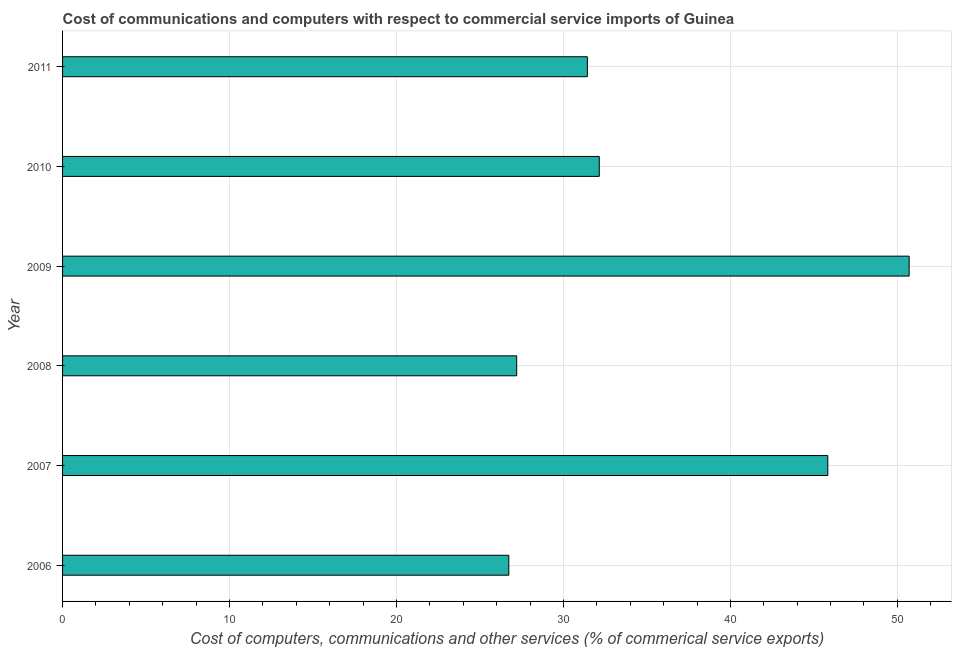Does the graph contain any zero values?
Offer a terse response. No. Does the graph contain grids?
Provide a succinct answer. Yes. What is the title of the graph?
Offer a terse response. Cost of communications and computers with respect to commercial service imports of Guinea. What is the label or title of the X-axis?
Keep it short and to the point. Cost of computers, communications and other services (% of commerical service exports). What is the label or title of the Y-axis?
Ensure brevity in your answer.  Year. What is the cost of communications in 2011?
Make the answer very short. 31.43. Across all years, what is the maximum cost of communications?
Your response must be concise. 50.71. Across all years, what is the minimum  computer and other services?
Keep it short and to the point. 26.73. In which year was the  computer and other services maximum?
Make the answer very short. 2009. What is the sum of the cost of communications?
Your answer should be compact. 214.05. What is the difference between the  computer and other services in 2009 and 2010?
Your response must be concise. 18.56. What is the average  computer and other services per year?
Your response must be concise. 35.67. What is the median  computer and other services?
Offer a terse response. 31.79. In how many years, is the cost of communications greater than 24 %?
Make the answer very short. 6. Do a majority of the years between 2006 and 2011 (inclusive) have  computer and other services greater than 8 %?
Your answer should be compact. Yes. What is the ratio of the  computer and other services in 2006 to that in 2011?
Your answer should be compact. 0.85. Is the  computer and other services in 2007 less than that in 2008?
Offer a very short reply. No. What is the difference between the highest and the second highest cost of communications?
Make the answer very short. 4.87. Is the sum of the cost of communications in 2008 and 2009 greater than the maximum cost of communications across all years?
Give a very brief answer. Yes. What is the difference between the highest and the lowest cost of communications?
Ensure brevity in your answer.  23.98. How many bars are there?
Make the answer very short. 6. How many years are there in the graph?
Make the answer very short. 6. Are the values on the major ticks of X-axis written in scientific E-notation?
Your response must be concise. No. What is the Cost of computers, communications and other services (% of commerical service exports) of 2006?
Ensure brevity in your answer.  26.73. What is the Cost of computers, communications and other services (% of commerical service exports) in 2007?
Provide a short and direct response. 45.83. What is the Cost of computers, communications and other services (% of commerical service exports) in 2008?
Your response must be concise. 27.2. What is the Cost of computers, communications and other services (% of commerical service exports) in 2009?
Provide a succinct answer. 50.71. What is the Cost of computers, communications and other services (% of commerical service exports) of 2010?
Offer a terse response. 32.15. What is the Cost of computers, communications and other services (% of commerical service exports) in 2011?
Offer a very short reply. 31.43. What is the difference between the Cost of computers, communications and other services (% of commerical service exports) in 2006 and 2007?
Your response must be concise. -19.11. What is the difference between the Cost of computers, communications and other services (% of commerical service exports) in 2006 and 2008?
Make the answer very short. -0.47. What is the difference between the Cost of computers, communications and other services (% of commerical service exports) in 2006 and 2009?
Provide a succinct answer. -23.98. What is the difference between the Cost of computers, communications and other services (% of commerical service exports) in 2006 and 2010?
Offer a very short reply. -5.42. What is the difference between the Cost of computers, communications and other services (% of commerical service exports) in 2006 and 2011?
Provide a succinct answer. -4.71. What is the difference between the Cost of computers, communications and other services (% of commerical service exports) in 2007 and 2008?
Offer a very short reply. 18.63. What is the difference between the Cost of computers, communications and other services (% of commerical service exports) in 2007 and 2009?
Make the answer very short. -4.87. What is the difference between the Cost of computers, communications and other services (% of commerical service exports) in 2007 and 2010?
Provide a succinct answer. 13.69. What is the difference between the Cost of computers, communications and other services (% of commerical service exports) in 2007 and 2011?
Your response must be concise. 14.4. What is the difference between the Cost of computers, communications and other services (% of commerical service exports) in 2008 and 2009?
Your answer should be compact. -23.51. What is the difference between the Cost of computers, communications and other services (% of commerical service exports) in 2008 and 2010?
Your answer should be very brief. -4.95. What is the difference between the Cost of computers, communications and other services (% of commerical service exports) in 2008 and 2011?
Provide a short and direct response. -4.23. What is the difference between the Cost of computers, communications and other services (% of commerical service exports) in 2009 and 2010?
Offer a terse response. 18.56. What is the difference between the Cost of computers, communications and other services (% of commerical service exports) in 2009 and 2011?
Offer a very short reply. 19.27. What is the difference between the Cost of computers, communications and other services (% of commerical service exports) in 2010 and 2011?
Make the answer very short. 0.71. What is the ratio of the Cost of computers, communications and other services (% of commerical service exports) in 2006 to that in 2007?
Your answer should be very brief. 0.58. What is the ratio of the Cost of computers, communications and other services (% of commerical service exports) in 2006 to that in 2009?
Offer a terse response. 0.53. What is the ratio of the Cost of computers, communications and other services (% of commerical service exports) in 2006 to that in 2010?
Give a very brief answer. 0.83. What is the ratio of the Cost of computers, communications and other services (% of commerical service exports) in 2006 to that in 2011?
Provide a succinct answer. 0.85. What is the ratio of the Cost of computers, communications and other services (% of commerical service exports) in 2007 to that in 2008?
Your answer should be very brief. 1.69. What is the ratio of the Cost of computers, communications and other services (% of commerical service exports) in 2007 to that in 2009?
Offer a terse response. 0.9. What is the ratio of the Cost of computers, communications and other services (% of commerical service exports) in 2007 to that in 2010?
Make the answer very short. 1.43. What is the ratio of the Cost of computers, communications and other services (% of commerical service exports) in 2007 to that in 2011?
Keep it short and to the point. 1.46. What is the ratio of the Cost of computers, communications and other services (% of commerical service exports) in 2008 to that in 2009?
Ensure brevity in your answer.  0.54. What is the ratio of the Cost of computers, communications and other services (% of commerical service exports) in 2008 to that in 2010?
Keep it short and to the point. 0.85. What is the ratio of the Cost of computers, communications and other services (% of commerical service exports) in 2008 to that in 2011?
Provide a short and direct response. 0.86. What is the ratio of the Cost of computers, communications and other services (% of commerical service exports) in 2009 to that in 2010?
Your answer should be very brief. 1.58. What is the ratio of the Cost of computers, communications and other services (% of commerical service exports) in 2009 to that in 2011?
Offer a terse response. 1.61. 